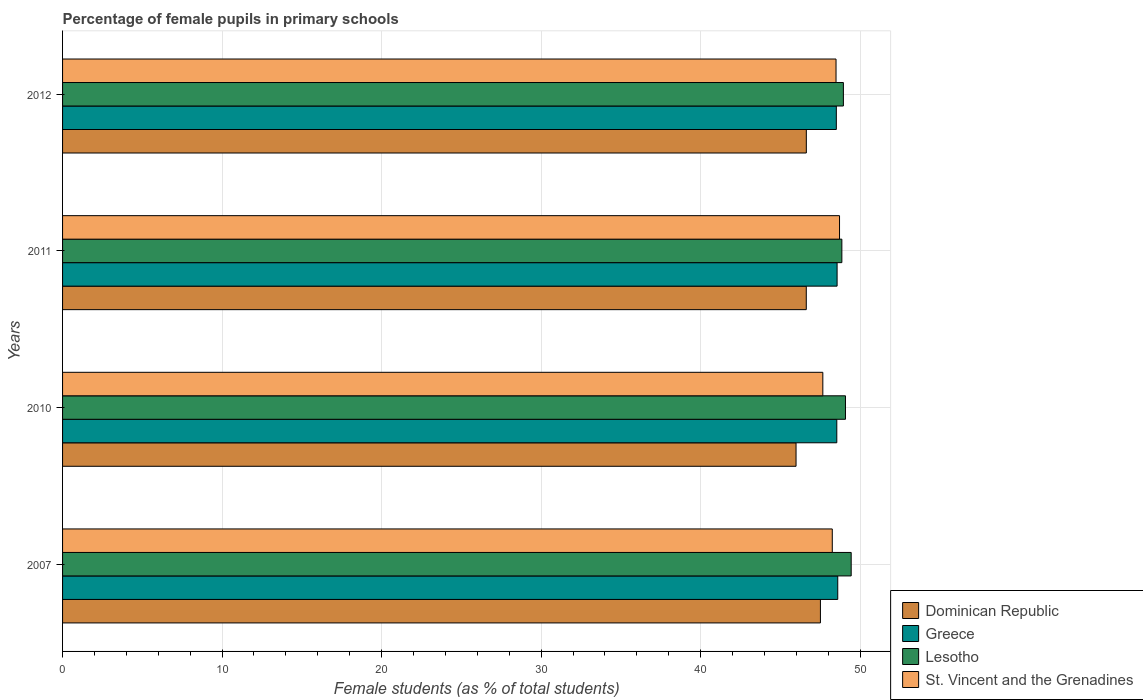How many groups of bars are there?
Make the answer very short. 4. Are the number of bars per tick equal to the number of legend labels?
Offer a very short reply. Yes. Are the number of bars on each tick of the Y-axis equal?
Offer a terse response. Yes. How many bars are there on the 2nd tick from the top?
Your answer should be very brief. 4. How many bars are there on the 3rd tick from the bottom?
Make the answer very short. 4. What is the label of the 2nd group of bars from the top?
Make the answer very short. 2011. What is the percentage of female pupils in primary schools in Lesotho in 2010?
Your answer should be very brief. 49.08. Across all years, what is the maximum percentage of female pupils in primary schools in St. Vincent and the Grenadines?
Ensure brevity in your answer.  48.71. Across all years, what is the minimum percentage of female pupils in primary schools in St. Vincent and the Grenadines?
Ensure brevity in your answer.  47.66. In which year was the percentage of female pupils in primary schools in St. Vincent and the Grenadines maximum?
Provide a succinct answer. 2011. In which year was the percentage of female pupils in primary schools in Dominican Republic minimum?
Keep it short and to the point. 2010. What is the total percentage of female pupils in primary schools in St. Vincent and the Grenadines in the graph?
Keep it short and to the point. 193.12. What is the difference between the percentage of female pupils in primary schools in Dominican Republic in 2010 and that in 2011?
Provide a short and direct response. -0.64. What is the difference between the percentage of female pupils in primary schools in Greece in 2011 and the percentage of female pupils in primary schools in Dominican Republic in 2007?
Provide a short and direct response. 1.05. What is the average percentage of female pupils in primary schools in Lesotho per year?
Offer a terse response. 49.08. In the year 2010, what is the difference between the percentage of female pupils in primary schools in St. Vincent and the Grenadines and percentage of female pupils in primary schools in Dominican Republic?
Ensure brevity in your answer.  1.68. In how many years, is the percentage of female pupils in primary schools in Lesotho greater than 18 %?
Offer a terse response. 4. What is the ratio of the percentage of female pupils in primary schools in St. Vincent and the Grenadines in 2010 to that in 2011?
Your answer should be compact. 0.98. Is the percentage of female pupils in primary schools in St. Vincent and the Grenadines in 2011 less than that in 2012?
Ensure brevity in your answer.  No. What is the difference between the highest and the second highest percentage of female pupils in primary schools in St. Vincent and the Grenadines?
Ensure brevity in your answer.  0.22. What is the difference between the highest and the lowest percentage of female pupils in primary schools in St. Vincent and the Grenadines?
Provide a succinct answer. 1.05. In how many years, is the percentage of female pupils in primary schools in St. Vincent and the Grenadines greater than the average percentage of female pupils in primary schools in St. Vincent and the Grenadines taken over all years?
Your response must be concise. 2. Is it the case that in every year, the sum of the percentage of female pupils in primary schools in Dominican Republic and percentage of female pupils in primary schools in St. Vincent and the Grenadines is greater than the sum of percentage of female pupils in primary schools in Greece and percentage of female pupils in primary schools in Lesotho?
Offer a very short reply. Yes. What does the 1st bar from the top in 2007 represents?
Offer a terse response. St. Vincent and the Grenadines. What does the 4th bar from the bottom in 2007 represents?
Offer a terse response. St. Vincent and the Grenadines. Is it the case that in every year, the sum of the percentage of female pupils in primary schools in Lesotho and percentage of female pupils in primary schools in Dominican Republic is greater than the percentage of female pupils in primary schools in St. Vincent and the Grenadines?
Ensure brevity in your answer.  Yes. How many bars are there?
Provide a succinct answer. 16. Are all the bars in the graph horizontal?
Make the answer very short. Yes. How many years are there in the graph?
Offer a terse response. 4. What is the difference between two consecutive major ticks on the X-axis?
Offer a terse response. 10. Are the values on the major ticks of X-axis written in scientific E-notation?
Offer a very short reply. No. Does the graph contain any zero values?
Offer a terse response. No. Does the graph contain grids?
Make the answer very short. Yes. How many legend labels are there?
Give a very brief answer. 4. How are the legend labels stacked?
Keep it short and to the point. Vertical. What is the title of the graph?
Your response must be concise. Percentage of female pupils in primary schools. What is the label or title of the X-axis?
Your answer should be very brief. Female students (as % of total students). What is the label or title of the Y-axis?
Provide a short and direct response. Years. What is the Female students (as % of total students) of Dominican Republic in 2007?
Ensure brevity in your answer.  47.51. What is the Female students (as % of total students) of Greece in 2007?
Offer a very short reply. 48.6. What is the Female students (as % of total students) of Lesotho in 2007?
Make the answer very short. 49.44. What is the Female students (as % of total students) of St. Vincent and the Grenadines in 2007?
Provide a succinct answer. 48.25. What is the Female students (as % of total students) of Dominican Republic in 2010?
Offer a very short reply. 45.98. What is the Female students (as % of total students) of Greece in 2010?
Your answer should be very brief. 48.54. What is the Female students (as % of total students) of Lesotho in 2010?
Give a very brief answer. 49.08. What is the Female students (as % of total students) of St. Vincent and the Grenadines in 2010?
Offer a very short reply. 47.66. What is the Female students (as % of total students) of Dominican Republic in 2011?
Give a very brief answer. 46.62. What is the Female students (as % of total students) in Greece in 2011?
Ensure brevity in your answer.  48.56. What is the Female students (as % of total students) in Lesotho in 2011?
Your answer should be very brief. 48.86. What is the Female students (as % of total students) in St. Vincent and the Grenadines in 2011?
Make the answer very short. 48.71. What is the Female students (as % of total students) of Dominican Republic in 2012?
Provide a succinct answer. 46.63. What is the Female students (as % of total students) in Greece in 2012?
Your answer should be compact. 48.51. What is the Female students (as % of total students) of Lesotho in 2012?
Offer a very short reply. 48.95. What is the Female students (as % of total students) in St. Vincent and the Grenadines in 2012?
Your answer should be compact. 48.49. Across all years, what is the maximum Female students (as % of total students) in Dominican Republic?
Make the answer very short. 47.51. Across all years, what is the maximum Female students (as % of total students) in Greece?
Make the answer very short. 48.6. Across all years, what is the maximum Female students (as % of total students) in Lesotho?
Ensure brevity in your answer.  49.44. Across all years, what is the maximum Female students (as % of total students) in St. Vincent and the Grenadines?
Provide a succinct answer. 48.71. Across all years, what is the minimum Female students (as % of total students) of Dominican Republic?
Offer a terse response. 45.98. Across all years, what is the minimum Female students (as % of total students) of Greece?
Provide a short and direct response. 48.51. Across all years, what is the minimum Female students (as % of total students) in Lesotho?
Offer a terse response. 48.86. Across all years, what is the minimum Female students (as % of total students) of St. Vincent and the Grenadines?
Ensure brevity in your answer.  47.66. What is the total Female students (as % of total students) in Dominican Republic in the graph?
Offer a very short reply. 186.75. What is the total Female students (as % of total students) in Greece in the graph?
Offer a very short reply. 194.2. What is the total Female students (as % of total students) of Lesotho in the graph?
Your answer should be compact. 196.33. What is the total Female students (as % of total students) in St. Vincent and the Grenadines in the graph?
Offer a terse response. 193.12. What is the difference between the Female students (as % of total students) of Dominican Republic in 2007 and that in 2010?
Ensure brevity in your answer.  1.53. What is the difference between the Female students (as % of total students) in Greece in 2007 and that in 2010?
Your answer should be very brief. 0.06. What is the difference between the Female students (as % of total students) of Lesotho in 2007 and that in 2010?
Offer a very short reply. 0.36. What is the difference between the Female students (as % of total students) of St. Vincent and the Grenadines in 2007 and that in 2010?
Offer a very short reply. 0.59. What is the difference between the Female students (as % of total students) in Dominican Republic in 2007 and that in 2011?
Your answer should be compact. 0.89. What is the difference between the Female students (as % of total students) in Greece in 2007 and that in 2011?
Offer a very short reply. 0.04. What is the difference between the Female students (as % of total students) in Lesotho in 2007 and that in 2011?
Make the answer very short. 0.58. What is the difference between the Female students (as % of total students) in St. Vincent and the Grenadines in 2007 and that in 2011?
Your response must be concise. -0.45. What is the difference between the Female students (as % of total students) in Dominican Republic in 2007 and that in 2012?
Your answer should be very brief. 0.88. What is the difference between the Female students (as % of total students) of Greece in 2007 and that in 2012?
Your answer should be very brief. 0.09. What is the difference between the Female students (as % of total students) in Lesotho in 2007 and that in 2012?
Offer a very short reply. 0.49. What is the difference between the Female students (as % of total students) of St. Vincent and the Grenadines in 2007 and that in 2012?
Give a very brief answer. -0.24. What is the difference between the Female students (as % of total students) in Dominican Republic in 2010 and that in 2011?
Your answer should be compact. -0.64. What is the difference between the Female students (as % of total students) in Greece in 2010 and that in 2011?
Your answer should be compact. -0.02. What is the difference between the Female students (as % of total students) of Lesotho in 2010 and that in 2011?
Offer a terse response. 0.23. What is the difference between the Female students (as % of total students) of St. Vincent and the Grenadines in 2010 and that in 2011?
Offer a very short reply. -1.05. What is the difference between the Female students (as % of total students) of Dominican Republic in 2010 and that in 2012?
Offer a terse response. -0.65. What is the difference between the Female students (as % of total students) in Greece in 2010 and that in 2012?
Provide a short and direct response. 0.03. What is the difference between the Female students (as % of total students) in Lesotho in 2010 and that in 2012?
Your response must be concise. 0.13. What is the difference between the Female students (as % of total students) of St. Vincent and the Grenadines in 2010 and that in 2012?
Your answer should be very brief. -0.83. What is the difference between the Female students (as % of total students) of Dominican Republic in 2011 and that in 2012?
Your answer should be very brief. -0. What is the difference between the Female students (as % of total students) in Greece in 2011 and that in 2012?
Offer a very short reply. 0.05. What is the difference between the Female students (as % of total students) of Lesotho in 2011 and that in 2012?
Your answer should be compact. -0.1. What is the difference between the Female students (as % of total students) of St. Vincent and the Grenadines in 2011 and that in 2012?
Your answer should be very brief. 0.22. What is the difference between the Female students (as % of total students) in Dominican Republic in 2007 and the Female students (as % of total students) in Greece in 2010?
Offer a terse response. -1.03. What is the difference between the Female students (as % of total students) in Dominican Republic in 2007 and the Female students (as % of total students) in Lesotho in 2010?
Provide a short and direct response. -1.57. What is the difference between the Female students (as % of total students) in Dominican Republic in 2007 and the Female students (as % of total students) in St. Vincent and the Grenadines in 2010?
Give a very brief answer. -0.15. What is the difference between the Female students (as % of total students) of Greece in 2007 and the Female students (as % of total students) of Lesotho in 2010?
Make the answer very short. -0.48. What is the difference between the Female students (as % of total students) of Greece in 2007 and the Female students (as % of total students) of St. Vincent and the Grenadines in 2010?
Your response must be concise. 0.94. What is the difference between the Female students (as % of total students) in Lesotho in 2007 and the Female students (as % of total students) in St. Vincent and the Grenadines in 2010?
Ensure brevity in your answer.  1.78. What is the difference between the Female students (as % of total students) of Dominican Republic in 2007 and the Female students (as % of total students) of Greece in 2011?
Offer a terse response. -1.05. What is the difference between the Female students (as % of total students) of Dominican Republic in 2007 and the Female students (as % of total students) of Lesotho in 2011?
Offer a very short reply. -1.34. What is the difference between the Female students (as % of total students) in Dominican Republic in 2007 and the Female students (as % of total students) in St. Vincent and the Grenadines in 2011?
Your response must be concise. -1.2. What is the difference between the Female students (as % of total students) in Greece in 2007 and the Female students (as % of total students) in Lesotho in 2011?
Your response must be concise. -0.26. What is the difference between the Female students (as % of total students) in Greece in 2007 and the Female students (as % of total students) in St. Vincent and the Grenadines in 2011?
Give a very brief answer. -0.11. What is the difference between the Female students (as % of total students) of Lesotho in 2007 and the Female students (as % of total students) of St. Vincent and the Grenadines in 2011?
Give a very brief answer. 0.73. What is the difference between the Female students (as % of total students) of Dominican Republic in 2007 and the Female students (as % of total students) of Greece in 2012?
Make the answer very short. -1. What is the difference between the Female students (as % of total students) in Dominican Republic in 2007 and the Female students (as % of total students) in Lesotho in 2012?
Your response must be concise. -1.44. What is the difference between the Female students (as % of total students) of Dominican Republic in 2007 and the Female students (as % of total students) of St. Vincent and the Grenadines in 2012?
Make the answer very short. -0.98. What is the difference between the Female students (as % of total students) in Greece in 2007 and the Female students (as % of total students) in Lesotho in 2012?
Make the answer very short. -0.35. What is the difference between the Female students (as % of total students) in Greece in 2007 and the Female students (as % of total students) in St. Vincent and the Grenadines in 2012?
Make the answer very short. 0.11. What is the difference between the Female students (as % of total students) of Lesotho in 2007 and the Female students (as % of total students) of St. Vincent and the Grenadines in 2012?
Provide a short and direct response. 0.95. What is the difference between the Female students (as % of total students) of Dominican Republic in 2010 and the Female students (as % of total students) of Greece in 2011?
Offer a terse response. -2.57. What is the difference between the Female students (as % of total students) of Dominican Republic in 2010 and the Female students (as % of total students) of Lesotho in 2011?
Offer a terse response. -2.87. What is the difference between the Female students (as % of total students) of Dominican Republic in 2010 and the Female students (as % of total students) of St. Vincent and the Grenadines in 2011?
Ensure brevity in your answer.  -2.73. What is the difference between the Female students (as % of total students) of Greece in 2010 and the Female students (as % of total students) of Lesotho in 2011?
Make the answer very short. -0.32. What is the difference between the Female students (as % of total students) of Greece in 2010 and the Female students (as % of total students) of St. Vincent and the Grenadines in 2011?
Offer a very short reply. -0.17. What is the difference between the Female students (as % of total students) in Lesotho in 2010 and the Female students (as % of total students) in St. Vincent and the Grenadines in 2011?
Offer a terse response. 0.37. What is the difference between the Female students (as % of total students) of Dominican Republic in 2010 and the Female students (as % of total students) of Greece in 2012?
Offer a very short reply. -2.53. What is the difference between the Female students (as % of total students) in Dominican Republic in 2010 and the Female students (as % of total students) in Lesotho in 2012?
Keep it short and to the point. -2.97. What is the difference between the Female students (as % of total students) in Dominican Republic in 2010 and the Female students (as % of total students) in St. Vincent and the Grenadines in 2012?
Your answer should be compact. -2.51. What is the difference between the Female students (as % of total students) of Greece in 2010 and the Female students (as % of total students) of Lesotho in 2012?
Your answer should be very brief. -0.41. What is the difference between the Female students (as % of total students) in Greece in 2010 and the Female students (as % of total students) in St. Vincent and the Grenadines in 2012?
Ensure brevity in your answer.  0.05. What is the difference between the Female students (as % of total students) of Lesotho in 2010 and the Female students (as % of total students) of St. Vincent and the Grenadines in 2012?
Provide a short and direct response. 0.59. What is the difference between the Female students (as % of total students) of Dominican Republic in 2011 and the Female students (as % of total students) of Greece in 2012?
Make the answer very short. -1.88. What is the difference between the Female students (as % of total students) in Dominican Republic in 2011 and the Female students (as % of total students) in Lesotho in 2012?
Your answer should be very brief. -2.33. What is the difference between the Female students (as % of total students) of Dominican Republic in 2011 and the Female students (as % of total students) of St. Vincent and the Grenadines in 2012?
Give a very brief answer. -1.87. What is the difference between the Female students (as % of total students) in Greece in 2011 and the Female students (as % of total students) in Lesotho in 2012?
Offer a very short reply. -0.39. What is the difference between the Female students (as % of total students) of Greece in 2011 and the Female students (as % of total students) of St. Vincent and the Grenadines in 2012?
Your answer should be very brief. 0.07. What is the difference between the Female students (as % of total students) of Lesotho in 2011 and the Female students (as % of total students) of St. Vincent and the Grenadines in 2012?
Keep it short and to the point. 0.36. What is the average Female students (as % of total students) of Dominican Republic per year?
Keep it short and to the point. 46.69. What is the average Female students (as % of total students) of Greece per year?
Give a very brief answer. 48.55. What is the average Female students (as % of total students) in Lesotho per year?
Make the answer very short. 49.08. What is the average Female students (as % of total students) of St. Vincent and the Grenadines per year?
Your response must be concise. 48.28. In the year 2007, what is the difference between the Female students (as % of total students) in Dominican Republic and Female students (as % of total students) in Greece?
Provide a succinct answer. -1.09. In the year 2007, what is the difference between the Female students (as % of total students) of Dominican Republic and Female students (as % of total students) of Lesotho?
Make the answer very short. -1.93. In the year 2007, what is the difference between the Female students (as % of total students) of Dominican Republic and Female students (as % of total students) of St. Vincent and the Grenadines?
Offer a very short reply. -0.74. In the year 2007, what is the difference between the Female students (as % of total students) of Greece and Female students (as % of total students) of Lesotho?
Offer a very short reply. -0.84. In the year 2007, what is the difference between the Female students (as % of total students) in Greece and Female students (as % of total students) in St. Vincent and the Grenadines?
Make the answer very short. 0.34. In the year 2007, what is the difference between the Female students (as % of total students) in Lesotho and Female students (as % of total students) in St. Vincent and the Grenadines?
Make the answer very short. 1.19. In the year 2010, what is the difference between the Female students (as % of total students) of Dominican Republic and Female students (as % of total students) of Greece?
Your response must be concise. -2.55. In the year 2010, what is the difference between the Female students (as % of total students) of Dominican Republic and Female students (as % of total students) of Lesotho?
Provide a short and direct response. -3.1. In the year 2010, what is the difference between the Female students (as % of total students) in Dominican Republic and Female students (as % of total students) in St. Vincent and the Grenadines?
Provide a succinct answer. -1.68. In the year 2010, what is the difference between the Female students (as % of total students) of Greece and Female students (as % of total students) of Lesotho?
Keep it short and to the point. -0.54. In the year 2010, what is the difference between the Female students (as % of total students) of Greece and Female students (as % of total students) of St. Vincent and the Grenadines?
Ensure brevity in your answer.  0.88. In the year 2010, what is the difference between the Female students (as % of total students) in Lesotho and Female students (as % of total students) in St. Vincent and the Grenadines?
Keep it short and to the point. 1.42. In the year 2011, what is the difference between the Female students (as % of total students) in Dominican Republic and Female students (as % of total students) in Greece?
Give a very brief answer. -1.93. In the year 2011, what is the difference between the Female students (as % of total students) of Dominican Republic and Female students (as % of total students) of Lesotho?
Provide a succinct answer. -2.23. In the year 2011, what is the difference between the Female students (as % of total students) in Dominican Republic and Female students (as % of total students) in St. Vincent and the Grenadines?
Give a very brief answer. -2.08. In the year 2011, what is the difference between the Female students (as % of total students) in Greece and Female students (as % of total students) in Lesotho?
Keep it short and to the point. -0.3. In the year 2011, what is the difference between the Female students (as % of total students) of Greece and Female students (as % of total students) of St. Vincent and the Grenadines?
Keep it short and to the point. -0.15. In the year 2011, what is the difference between the Female students (as % of total students) of Lesotho and Female students (as % of total students) of St. Vincent and the Grenadines?
Provide a succinct answer. 0.15. In the year 2012, what is the difference between the Female students (as % of total students) of Dominican Republic and Female students (as % of total students) of Greece?
Make the answer very short. -1.88. In the year 2012, what is the difference between the Female students (as % of total students) of Dominican Republic and Female students (as % of total students) of Lesotho?
Your answer should be compact. -2.32. In the year 2012, what is the difference between the Female students (as % of total students) of Dominican Republic and Female students (as % of total students) of St. Vincent and the Grenadines?
Make the answer very short. -1.86. In the year 2012, what is the difference between the Female students (as % of total students) of Greece and Female students (as % of total students) of Lesotho?
Provide a succinct answer. -0.44. In the year 2012, what is the difference between the Female students (as % of total students) in Greece and Female students (as % of total students) in St. Vincent and the Grenadines?
Provide a short and direct response. 0.02. In the year 2012, what is the difference between the Female students (as % of total students) of Lesotho and Female students (as % of total students) of St. Vincent and the Grenadines?
Offer a terse response. 0.46. What is the ratio of the Female students (as % of total students) in Dominican Republic in 2007 to that in 2010?
Provide a succinct answer. 1.03. What is the ratio of the Female students (as % of total students) in Greece in 2007 to that in 2010?
Keep it short and to the point. 1. What is the ratio of the Female students (as % of total students) in Lesotho in 2007 to that in 2010?
Your response must be concise. 1.01. What is the ratio of the Female students (as % of total students) in St. Vincent and the Grenadines in 2007 to that in 2010?
Offer a very short reply. 1.01. What is the ratio of the Female students (as % of total students) in Dominican Republic in 2007 to that in 2011?
Make the answer very short. 1.02. What is the ratio of the Female students (as % of total students) of Greece in 2007 to that in 2011?
Offer a very short reply. 1. What is the ratio of the Female students (as % of total students) of Lesotho in 2007 to that in 2011?
Ensure brevity in your answer.  1.01. What is the ratio of the Female students (as % of total students) in Greece in 2007 to that in 2012?
Give a very brief answer. 1. What is the ratio of the Female students (as % of total students) in Lesotho in 2007 to that in 2012?
Ensure brevity in your answer.  1.01. What is the ratio of the Female students (as % of total students) of St. Vincent and the Grenadines in 2007 to that in 2012?
Provide a short and direct response. 1. What is the ratio of the Female students (as % of total students) of Dominican Republic in 2010 to that in 2011?
Make the answer very short. 0.99. What is the ratio of the Female students (as % of total students) in Lesotho in 2010 to that in 2011?
Provide a short and direct response. 1. What is the ratio of the Female students (as % of total students) of St. Vincent and the Grenadines in 2010 to that in 2011?
Offer a terse response. 0.98. What is the ratio of the Female students (as % of total students) of Dominican Republic in 2010 to that in 2012?
Your response must be concise. 0.99. What is the ratio of the Female students (as % of total students) of Greece in 2010 to that in 2012?
Ensure brevity in your answer.  1. What is the ratio of the Female students (as % of total students) of St. Vincent and the Grenadines in 2010 to that in 2012?
Your answer should be compact. 0.98. What is the ratio of the Female students (as % of total students) of Lesotho in 2011 to that in 2012?
Offer a very short reply. 1. What is the difference between the highest and the second highest Female students (as % of total students) of Dominican Republic?
Offer a terse response. 0.88. What is the difference between the highest and the second highest Female students (as % of total students) of Greece?
Keep it short and to the point. 0.04. What is the difference between the highest and the second highest Female students (as % of total students) of Lesotho?
Keep it short and to the point. 0.36. What is the difference between the highest and the second highest Female students (as % of total students) in St. Vincent and the Grenadines?
Your response must be concise. 0.22. What is the difference between the highest and the lowest Female students (as % of total students) of Dominican Republic?
Your answer should be very brief. 1.53. What is the difference between the highest and the lowest Female students (as % of total students) of Greece?
Your answer should be compact. 0.09. What is the difference between the highest and the lowest Female students (as % of total students) of Lesotho?
Provide a short and direct response. 0.58. What is the difference between the highest and the lowest Female students (as % of total students) of St. Vincent and the Grenadines?
Provide a short and direct response. 1.05. 